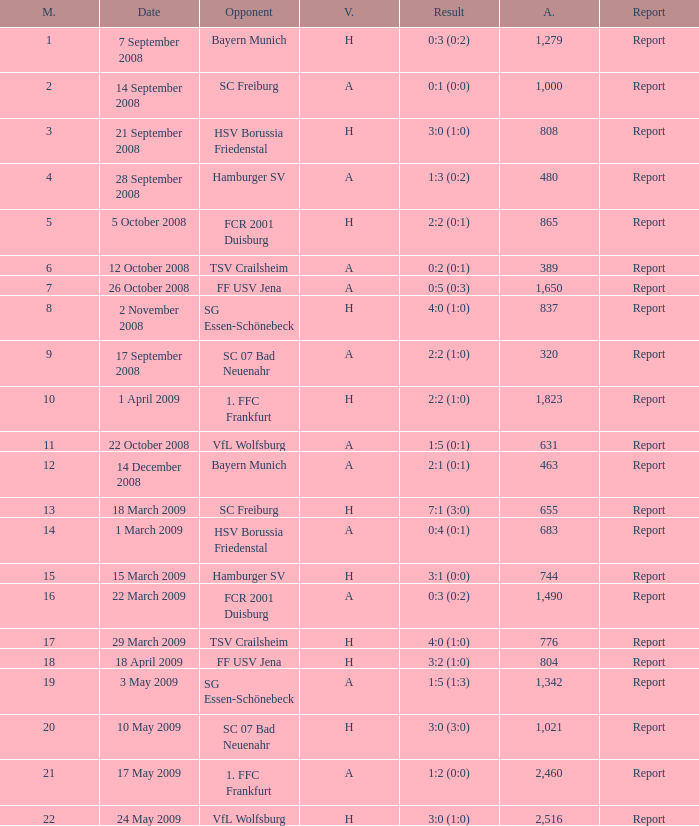What is the match number that had a result of 0:5 (0:3)? 1.0. 